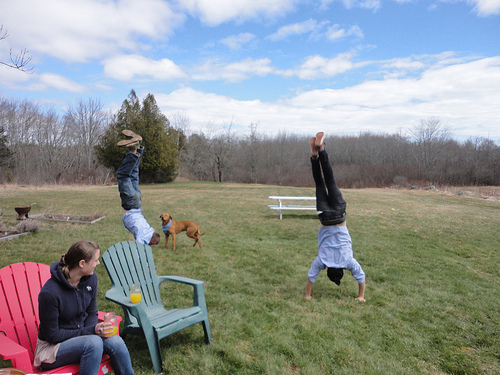<image>
Can you confirm if the dog is above the lady? No. The dog is not positioned above the lady. The vertical arrangement shows a different relationship. Where is the man in relation to the chair? Is it on the chair? No. The man is not positioned on the chair. They may be near each other, but the man is not supported by or resting on top of the chair. Is there a dog to the left of the man? Yes. From this viewpoint, the dog is positioned to the left side relative to the man. 